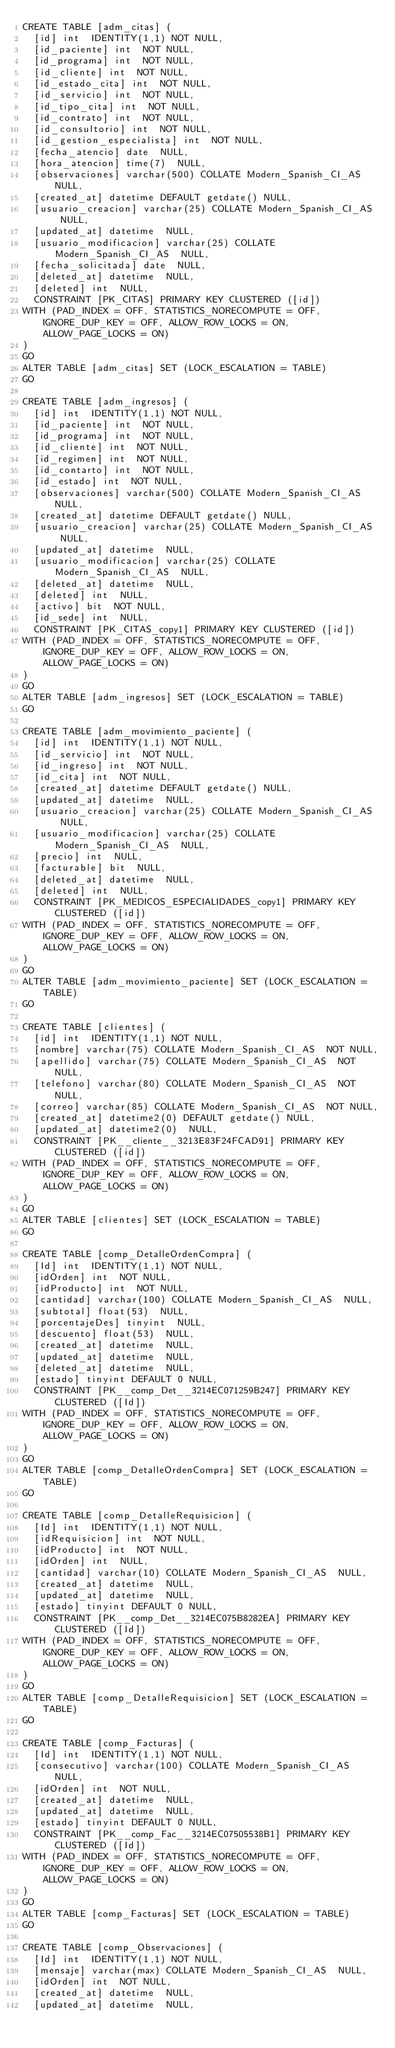<code> <loc_0><loc_0><loc_500><loc_500><_SQL_>CREATE TABLE [adm_citas] (
  [id] int  IDENTITY(1,1) NOT NULL,
  [id_paciente] int  NOT NULL,
  [id_programa] int  NOT NULL,
  [id_cliente] int  NOT NULL,
  [id_estado_cita] int  NOT NULL,
  [id_servicio] int  NOT NULL,
  [id_tipo_cita] int  NOT NULL,
  [id_contrato] int  NOT NULL,
  [id_consultorio] int  NOT NULL,
  [id_gestion_especialista] int  NOT NULL,
  [fecha_atencio] date  NULL,
  [hora_atencion] time(7)  NULL,
  [observaciones] varchar(500) COLLATE Modern_Spanish_CI_AS  NULL,
  [created_at] datetime DEFAULT getdate() NULL,
  [usuario_creacion] varchar(25) COLLATE Modern_Spanish_CI_AS  NULL,
  [updated_at] datetime  NULL,
  [usuario_modificacion] varchar(25) COLLATE Modern_Spanish_CI_AS  NULL,
  [fecha_solicitada] date  NULL,
  [deleted_at] datetime  NULL,
  [deleted] int  NULL,
  CONSTRAINT [PK_CITAS] PRIMARY KEY CLUSTERED ([id])
WITH (PAD_INDEX = OFF, STATISTICS_NORECOMPUTE = OFF, IGNORE_DUP_KEY = OFF, ALLOW_ROW_LOCKS = ON, ALLOW_PAGE_LOCKS = ON)
)
GO
ALTER TABLE [adm_citas] SET (LOCK_ESCALATION = TABLE)
GO

CREATE TABLE [adm_ingresos] (
  [id] int  IDENTITY(1,1) NOT NULL,
  [id_paciente] int  NOT NULL,
  [id_programa] int  NOT NULL,
  [id_cliente] int  NOT NULL,
  [id_regimen] int  NOT NULL,
  [id_contarto] int  NOT NULL,
  [id_estado] int  NOT NULL,
  [observaciones] varchar(500) COLLATE Modern_Spanish_CI_AS  NULL,
  [created_at] datetime DEFAULT getdate() NULL,
  [usuario_creacion] varchar(25) COLLATE Modern_Spanish_CI_AS  NULL,
  [updated_at] datetime  NULL,
  [usuario_modificacion] varchar(25) COLLATE Modern_Spanish_CI_AS  NULL,
  [deleted_at] datetime  NULL,
  [deleted] int  NULL,
  [activo] bit  NOT NULL,
  [id_sede] int  NULL,
  CONSTRAINT [PK_CITAS_copy1] PRIMARY KEY CLUSTERED ([id])
WITH (PAD_INDEX = OFF, STATISTICS_NORECOMPUTE = OFF, IGNORE_DUP_KEY = OFF, ALLOW_ROW_LOCKS = ON, ALLOW_PAGE_LOCKS = ON)
)
GO
ALTER TABLE [adm_ingresos] SET (LOCK_ESCALATION = TABLE)
GO

CREATE TABLE [adm_movimiento_paciente] (
  [id] int  IDENTITY(1,1) NOT NULL,
  [id_servicio] int  NOT NULL,
  [id_ingreso] int  NOT NULL,
  [id_cita] int  NOT NULL,
  [created_at] datetime DEFAULT getdate() NULL,
  [updated_at] datetime  NULL,
  [usuario_creacion] varchar(25) COLLATE Modern_Spanish_CI_AS  NULL,
  [usuario_modificacion] varchar(25) COLLATE Modern_Spanish_CI_AS  NULL,
  [precio] int  NULL,
  [facturable] bit  NULL,
  [deleted_at] datetime  NULL,
  [deleted] int  NULL,
  CONSTRAINT [PK_MEDICOS_ESPECIALIDADES_copy1] PRIMARY KEY CLUSTERED ([id])
WITH (PAD_INDEX = OFF, STATISTICS_NORECOMPUTE = OFF, IGNORE_DUP_KEY = OFF, ALLOW_ROW_LOCKS = ON, ALLOW_PAGE_LOCKS = ON)
)
GO
ALTER TABLE [adm_movimiento_paciente] SET (LOCK_ESCALATION = TABLE)
GO

CREATE TABLE [clientes] (
  [id] int  IDENTITY(1,1) NOT NULL,
  [nombre] varchar(75) COLLATE Modern_Spanish_CI_AS  NOT NULL,
  [apellido] varchar(75) COLLATE Modern_Spanish_CI_AS  NOT NULL,
  [telefono] varchar(80) COLLATE Modern_Spanish_CI_AS  NOT NULL,
  [correo] varchar(85) COLLATE Modern_Spanish_CI_AS  NOT NULL,
  [created_at] datetime2(0) DEFAULT getdate() NULL,
  [updated_at] datetime2(0)  NULL,
  CONSTRAINT [PK__cliente__3213E83F24FCAD91] PRIMARY KEY CLUSTERED ([id])
WITH (PAD_INDEX = OFF, STATISTICS_NORECOMPUTE = OFF, IGNORE_DUP_KEY = OFF, ALLOW_ROW_LOCKS = ON, ALLOW_PAGE_LOCKS = ON)
)
GO
ALTER TABLE [clientes] SET (LOCK_ESCALATION = TABLE)
GO

CREATE TABLE [comp_DetalleOrdenCompra] (
  [Id] int  IDENTITY(1,1) NOT NULL,
  [idOrden] int  NOT NULL,
  [idProducto] int  NOT NULL,
  [cantidad] varchar(100) COLLATE Modern_Spanish_CI_AS  NULL,
  [subtotal] float(53)  NULL,
  [porcentajeDes] tinyint  NULL,
  [descuento] float(53)  NULL,
  [created_at] datetime  NULL,
  [updated_at] datetime  NULL,
  [deleted_at] datetime  NULL,
  [estado] tinyint DEFAULT 0 NULL,
  CONSTRAINT [PK__comp_Det__3214EC071259B247] PRIMARY KEY CLUSTERED ([Id])
WITH (PAD_INDEX = OFF, STATISTICS_NORECOMPUTE = OFF, IGNORE_DUP_KEY = OFF, ALLOW_ROW_LOCKS = ON, ALLOW_PAGE_LOCKS = ON)
)
GO
ALTER TABLE [comp_DetalleOrdenCompra] SET (LOCK_ESCALATION = TABLE)
GO

CREATE TABLE [comp_DetalleRequisicion] (
  [Id] int  IDENTITY(1,1) NOT NULL,
  [idRequisicion] int  NOT NULL,
  [idProducto] int  NOT NULL,
  [idOrden] int  NULL,
  [cantidad] varchar(10) COLLATE Modern_Spanish_CI_AS  NULL,
  [created_at] datetime  NULL,
  [updated_at] datetime  NULL,
  [estado] tinyint DEFAULT 0 NULL,
  CONSTRAINT [PK__comp_Det__3214EC075B8282EA] PRIMARY KEY CLUSTERED ([Id])
WITH (PAD_INDEX = OFF, STATISTICS_NORECOMPUTE = OFF, IGNORE_DUP_KEY = OFF, ALLOW_ROW_LOCKS = ON, ALLOW_PAGE_LOCKS = ON)
)
GO
ALTER TABLE [comp_DetalleRequisicion] SET (LOCK_ESCALATION = TABLE)
GO

CREATE TABLE [comp_Facturas] (
  [Id] int  IDENTITY(1,1) NOT NULL,
  [consecutivo] varchar(100) COLLATE Modern_Spanish_CI_AS  NULL,
  [idOrden] int  NOT NULL,
  [created_at] datetime  NULL,
  [updated_at] datetime  NULL,
  [estado] tinyint DEFAULT 0 NULL,
  CONSTRAINT [PK__comp_Fac__3214EC07505538B1] PRIMARY KEY CLUSTERED ([Id])
WITH (PAD_INDEX = OFF, STATISTICS_NORECOMPUTE = OFF, IGNORE_DUP_KEY = OFF, ALLOW_ROW_LOCKS = ON, ALLOW_PAGE_LOCKS = ON)
)
GO
ALTER TABLE [comp_Facturas] SET (LOCK_ESCALATION = TABLE)
GO

CREATE TABLE [comp_Observaciones] (
  [Id] int  IDENTITY(1,1) NOT NULL,
  [mensaje] varchar(max) COLLATE Modern_Spanish_CI_AS  NULL,
  [idOrden] int  NOT NULL,
  [created_at] datetime  NULL,
  [updated_at] datetime  NULL,</code> 